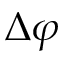<formula> <loc_0><loc_0><loc_500><loc_500>\Delta \varphi</formula> 